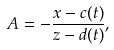<formula> <loc_0><loc_0><loc_500><loc_500>A = - \frac { x - c ( t ) } { z - d ( t ) } ,</formula> 